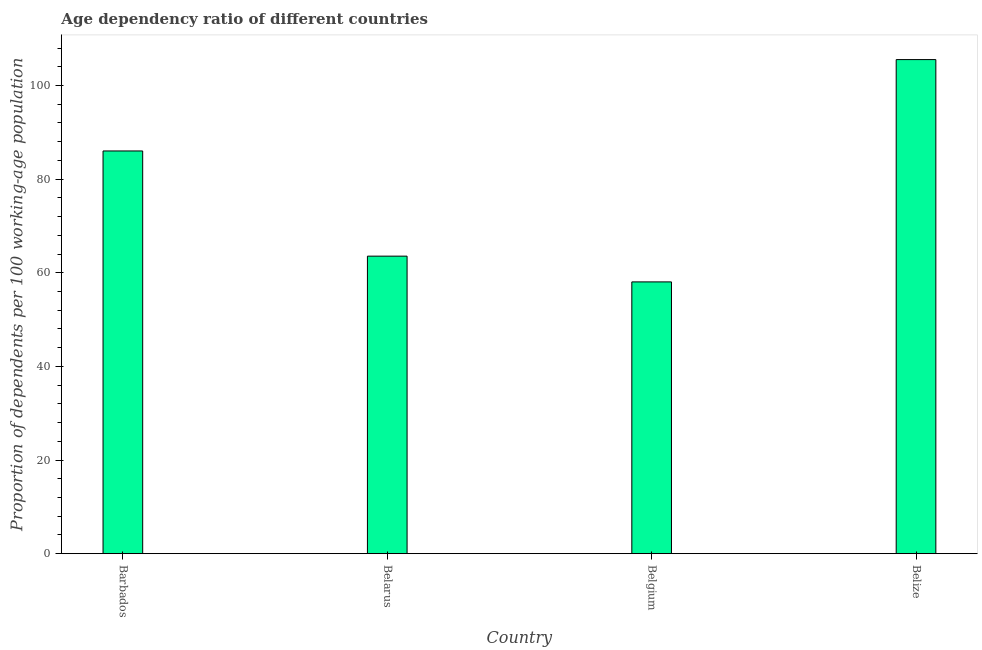What is the title of the graph?
Your answer should be compact. Age dependency ratio of different countries. What is the label or title of the X-axis?
Your answer should be compact. Country. What is the label or title of the Y-axis?
Your answer should be compact. Proportion of dependents per 100 working-age population. What is the age dependency ratio in Barbados?
Keep it short and to the point. 86.02. Across all countries, what is the maximum age dependency ratio?
Keep it short and to the point. 105.54. Across all countries, what is the minimum age dependency ratio?
Provide a succinct answer. 58.05. In which country was the age dependency ratio maximum?
Give a very brief answer. Belize. In which country was the age dependency ratio minimum?
Ensure brevity in your answer.  Belgium. What is the sum of the age dependency ratio?
Provide a succinct answer. 313.16. What is the difference between the age dependency ratio in Barbados and Belarus?
Your response must be concise. 22.47. What is the average age dependency ratio per country?
Your answer should be very brief. 78.29. What is the median age dependency ratio?
Your answer should be compact. 74.78. What is the ratio of the age dependency ratio in Belarus to that in Belize?
Give a very brief answer. 0.6. Is the age dependency ratio in Belarus less than that in Belgium?
Give a very brief answer. No. What is the difference between the highest and the second highest age dependency ratio?
Keep it short and to the point. 19.52. What is the difference between the highest and the lowest age dependency ratio?
Your answer should be very brief. 47.49. In how many countries, is the age dependency ratio greater than the average age dependency ratio taken over all countries?
Your response must be concise. 2. Are all the bars in the graph horizontal?
Your answer should be compact. No. What is the difference between two consecutive major ticks on the Y-axis?
Provide a succinct answer. 20. What is the Proportion of dependents per 100 working-age population in Barbados?
Ensure brevity in your answer.  86.02. What is the Proportion of dependents per 100 working-age population of Belarus?
Offer a terse response. 63.55. What is the Proportion of dependents per 100 working-age population of Belgium?
Provide a short and direct response. 58.05. What is the Proportion of dependents per 100 working-age population of Belize?
Offer a terse response. 105.54. What is the difference between the Proportion of dependents per 100 working-age population in Barbados and Belarus?
Make the answer very short. 22.47. What is the difference between the Proportion of dependents per 100 working-age population in Barbados and Belgium?
Your answer should be compact. 27.97. What is the difference between the Proportion of dependents per 100 working-age population in Barbados and Belize?
Provide a succinct answer. -19.52. What is the difference between the Proportion of dependents per 100 working-age population in Belarus and Belgium?
Ensure brevity in your answer.  5.5. What is the difference between the Proportion of dependents per 100 working-age population in Belarus and Belize?
Your answer should be compact. -41.99. What is the difference between the Proportion of dependents per 100 working-age population in Belgium and Belize?
Give a very brief answer. -47.49. What is the ratio of the Proportion of dependents per 100 working-age population in Barbados to that in Belarus?
Ensure brevity in your answer.  1.35. What is the ratio of the Proportion of dependents per 100 working-age population in Barbados to that in Belgium?
Your response must be concise. 1.48. What is the ratio of the Proportion of dependents per 100 working-age population in Barbados to that in Belize?
Make the answer very short. 0.81. What is the ratio of the Proportion of dependents per 100 working-age population in Belarus to that in Belgium?
Your response must be concise. 1.09. What is the ratio of the Proportion of dependents per 100 working-age population in Belarus to that in Belize?
Ensure brevity in your answer.  0.6. What is the ratio of the Proportion of dependents per 100 working-age population in Belgium to that in Belize?
Make the answer very short. 0.55. 